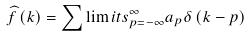Convert formula to latex. <formula><loc_0><loc_0><loc_500><loc_500>\widehat { f } \left ( k \right ) = \sum \lim i t s _ { p = - \infty } ^ { \infty } a _ { p } \delta \left ( k - p \right )</formula> 